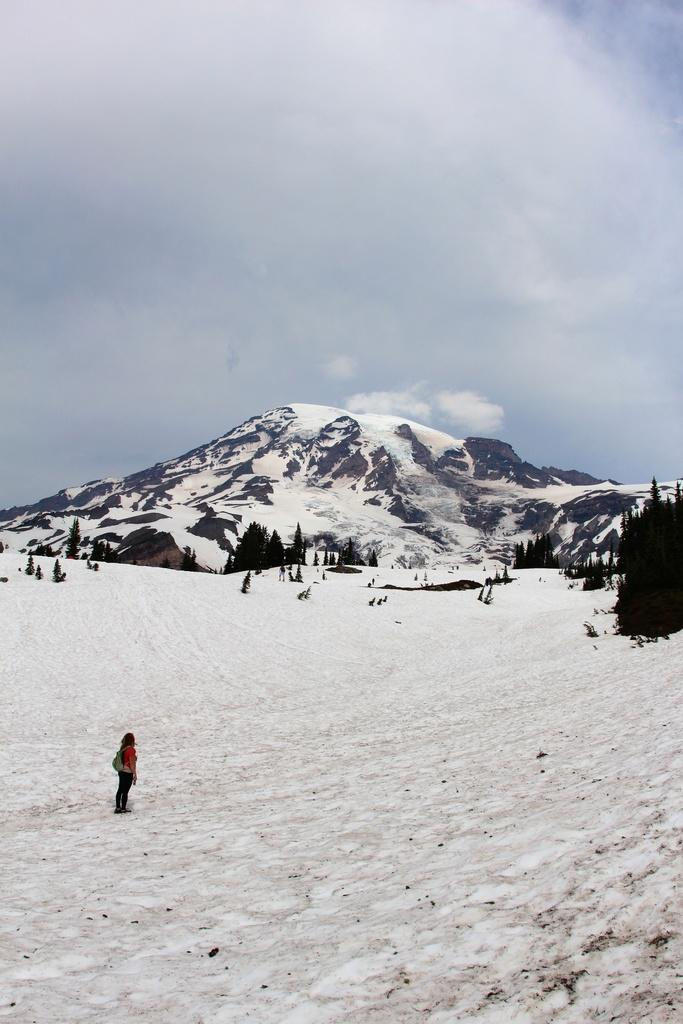What is the person in the image standing on? The person is standing on the ice. What can be seen in the background of the image? There are trees and mountains in the background of the image. What is the condition of the sky in the image? The sky is cloudy in the background of the image. What type of muscle can be seen flexing in the image? There is no muscle visible in the image, as it only shows a person standing on the ice with trees, mountains, and a cloudy sky in the background. 